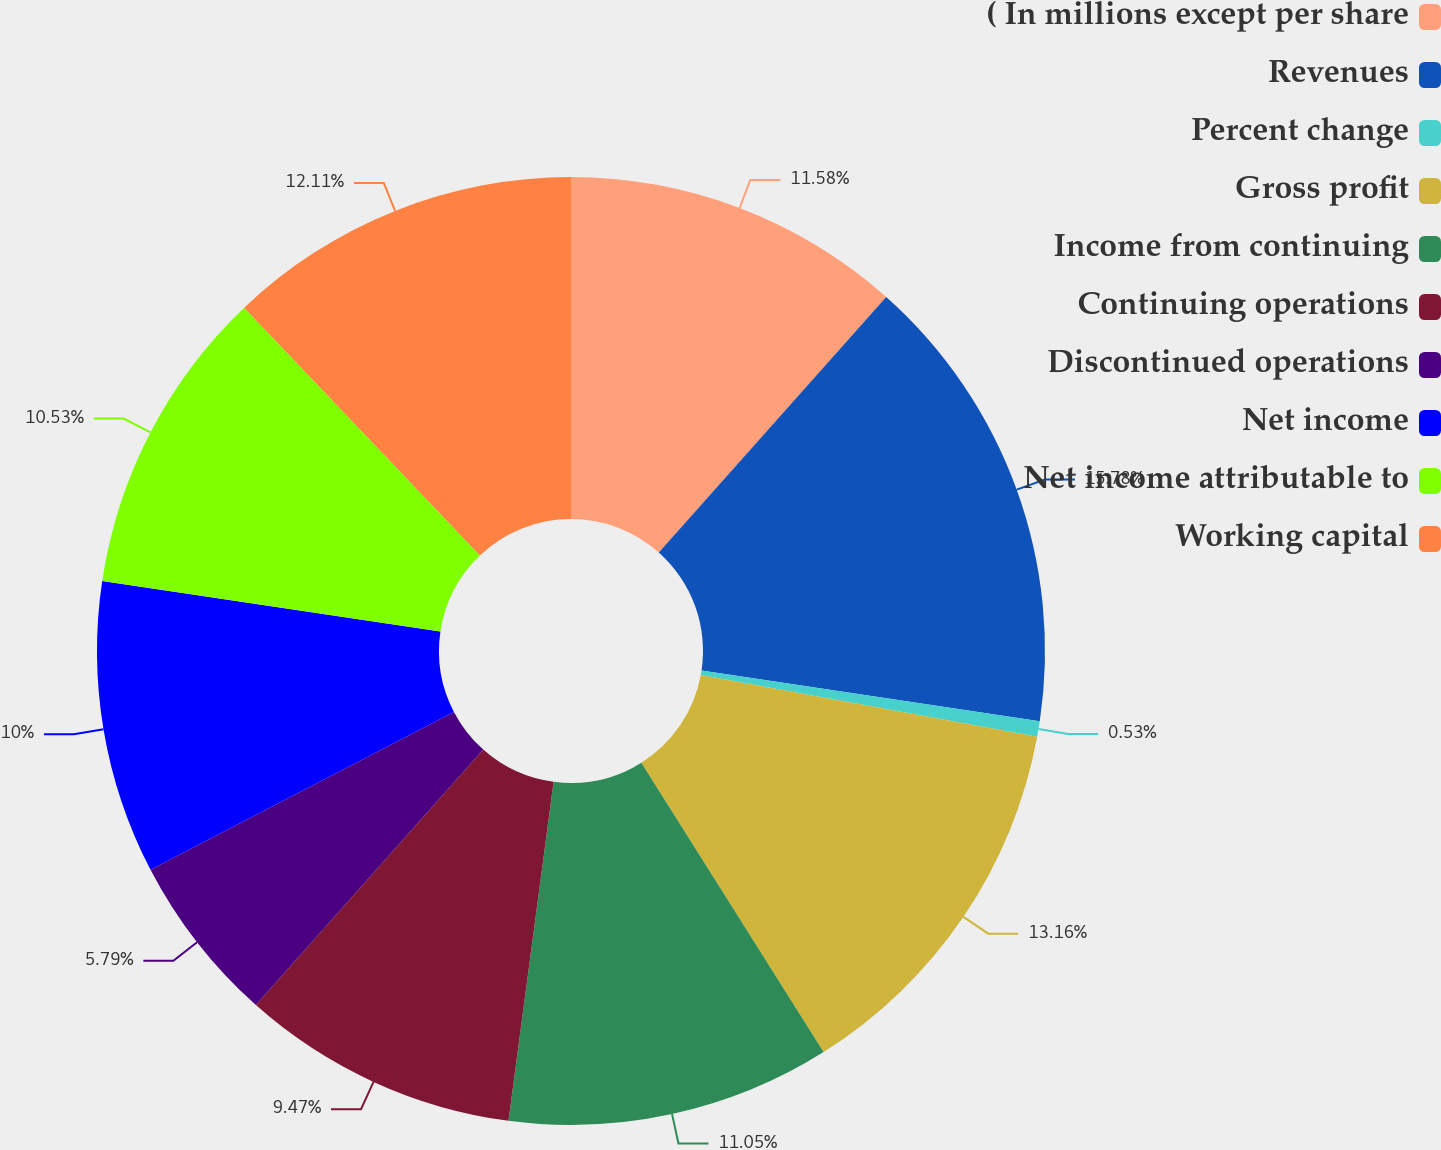Convert chart to OTSL. <chart><loc_0><loc_0><loc_500><loc_500><pie_chart><fcel>( In millions except per share<fcel>Revenues<fcel>Percent change<fcel>Gross profit<fcel>Income from continuing<fcel>Continuing operations<fcel>Discontinued operations<fcel>Net income<fcel>Net income attributable to<fcel>Working capital<nl><fcel>11.58%<fcel>15.79%<fcel>0.53%<fcel>13.16%<fcel>11.05%<fcel>9.47%<fcel>5.79%<fcel>10.0%<fcel>10.53%<fcel>12.11%<nl></chart> 